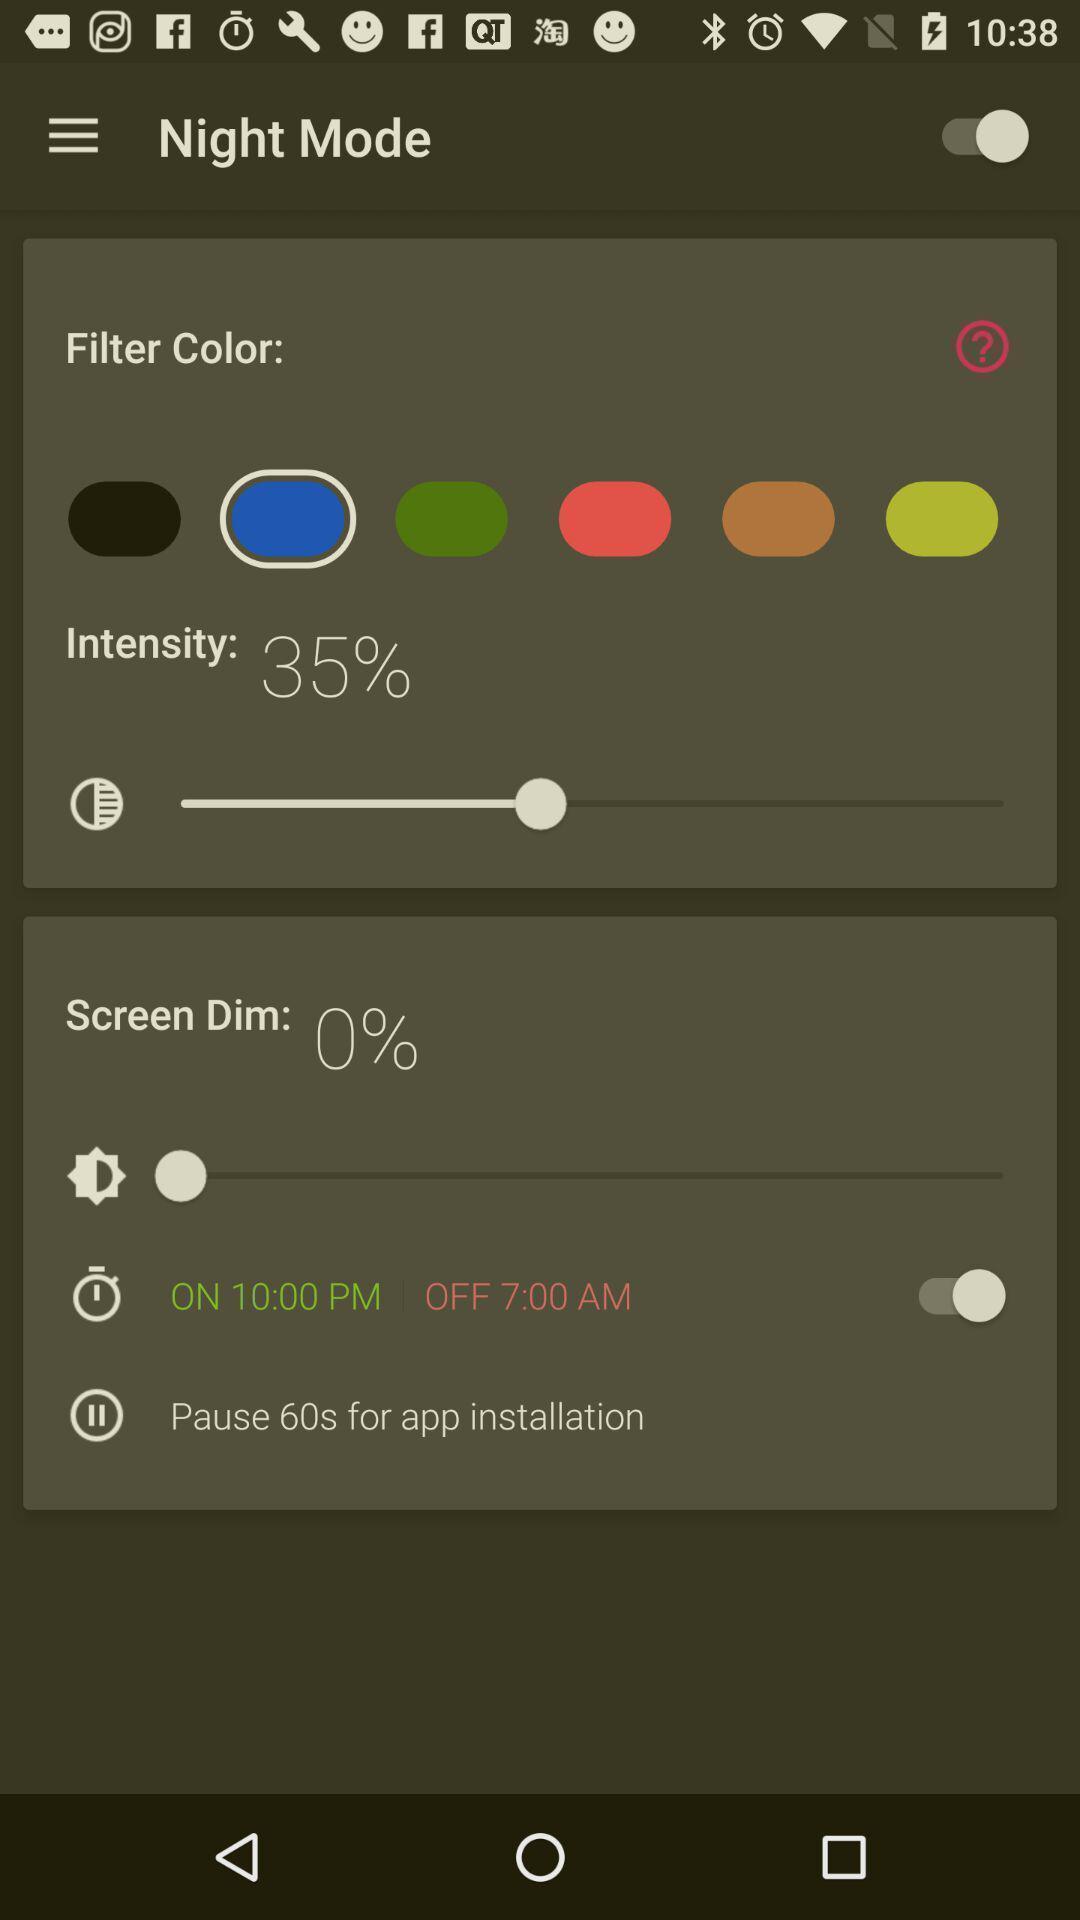Give me a narrative description of this picture. Page showing different options for setting night mode. 